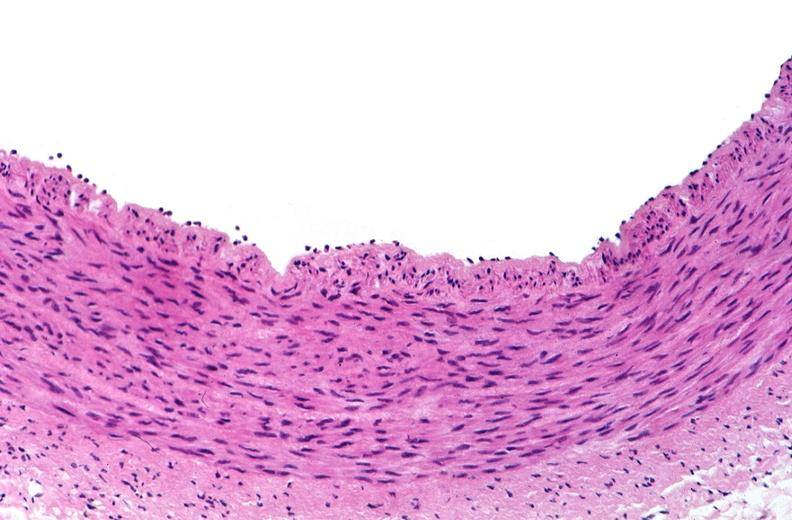s lymphangiomatosis generalized present?
Answer the question using a single word or phrase. No 